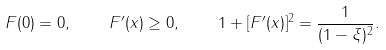<formula> <loc_0><loc_0><loc_500><loc_500>F ( 0 ) = 0 , \quad F ^ { \prime } ( x ) \geq 0 , \quad 1 + [ F ^ { \prime } ( x ) ] ^ { 2 } = \frac { 1 } { ( 1 - \xi ) ^ { 2 } } .</formula> 